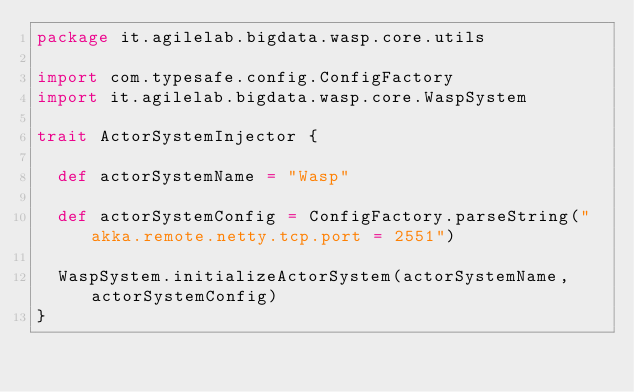<code> <loc_0><loc_0><loc_500><loc_500><_Scala_>package it.agilelab.bigdata.wasp.core.utils

import com.typesafe.config.ConfigFactory
import it.agilelab.bigdata.wasp.core.WaspSystem

trait ActorSystemInjector {

  def actorSystemName = "Wasp"

  def actorSystemConfig = ConfigFactory.parseString("akka.remote.netty.tcp.port = 2551")

  WaspSystem.initializeActorSystem(actorSystemName, actorSystemConfig)
}</code> 